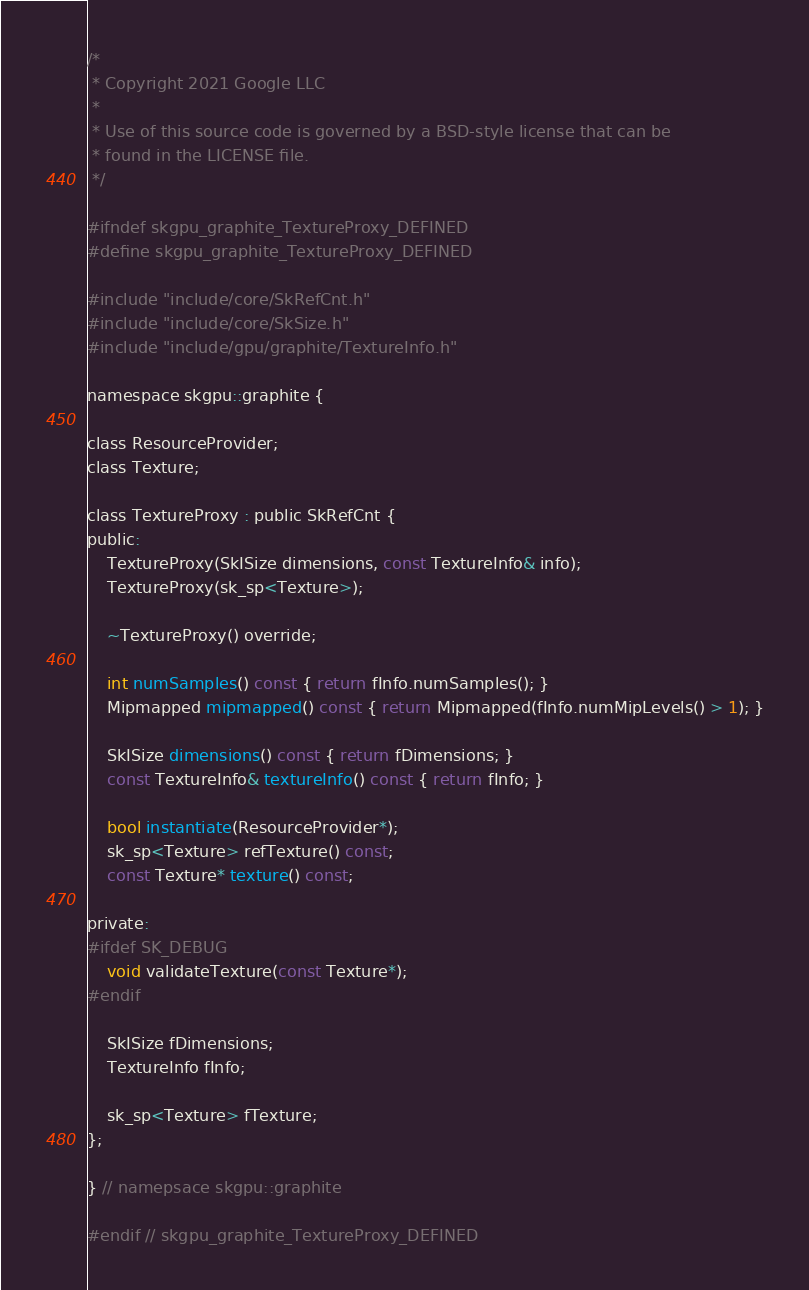Convert code to text. <code><loc_0><loc_0><loc_500><loc_500><_C_>/*
 * Copyright 2021 Google LLC
 *
 * Use of this source code is governed by a BSD-style license that can be
 * found in the LICENSE file.
 */

#ifndef skgpu_graphite_TextureProxy_DEFINED
#define skgpu_graphite_TextureProxy_DEFINED

#include "include/core/SkRefCnt.h"
#include "include/core/SkSize.h"
#include "include/gpu/graphite/TextureInfo.h"

namespace skgpu::graphite {

class ResourceProvider;
class Texture;

class TextureProxy : public SkRefCnt {
public:
    TextureProxy(SkISize dimensions, const TextureInfo& info);
    TextureProxy(sk_sp<Texture>);

    ~TextureProxy() override;

    int numSamples() const { return fInfo.numSamples(); }
    Mipmapped mipmapped() const { return Mipmapped(fInfo.numMipLevels() > 1); }

    SkISize dimensions() const { return fDimensions; }
    const TextureInfo& textureInfo() const { return fInfo; }

    bool instantiate(ResourceProvider*);
    sk_sp<Texture> refTexture() const;
    const Texture* texture() const;

private:
#ifdef SK_DEBUG
    void validateTexture(const Texture*);
#endif

    SkISize fDimensions;
    TextureInfo fInfo;

    sk_sp<Texture> fTexture;
};

} // namepsace skgpu::graphite

#endif // skgpu_graphite_TextureProxy_DEFINED
</code> 